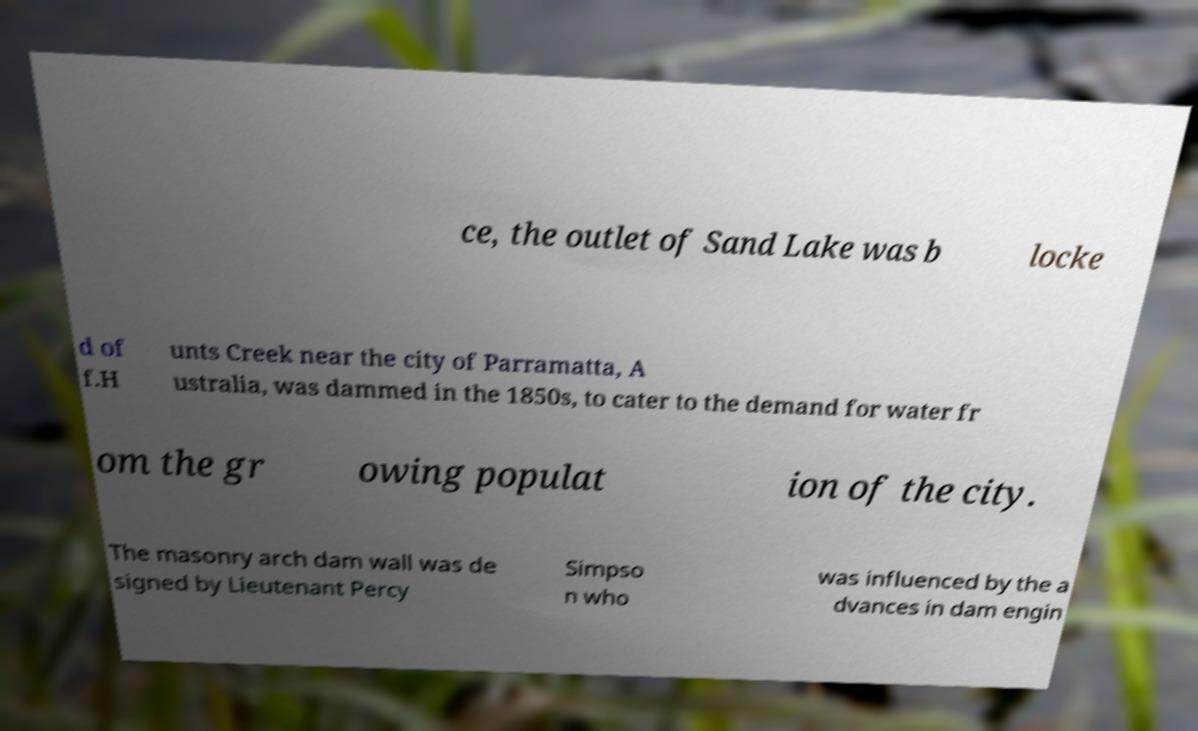Please identify and transcribe the text found in this image. ce, the outlet of Sand Lake was b locke d of f.H unts Creek near the city of Parramatta, A ustralia, was dammed in the 1850s, to cater to the demand for water fr om the gr owing populat ion of the city. The masonry arch dam wall was de signed by Lieutenant Percy Simpso n who was influenced by the a dvances in dam engin 